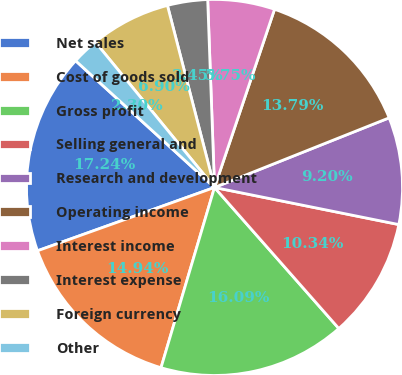Convert chart. <chart><loc_0><loc_0><loc_500><loc_500><pie_chart><fcel>Net sales<fcel>Cost of goods sold<fcel>Gross profit<fcel>Selling general and<fcel>Research and development<fcel>Operating income<fcel>Interest income<fcel>Interest expense<fcel>Foreign currency<fcel>Other<nl><fcel>17.24%<fcel>14.94%<fcel>16.09%<fcel>10.34%<fcel>9.2%<fcel>13.79%<fcel>5.75%<fcel>3.45%<fcel>6.9%<fcel>2.3%<nl></chart> 